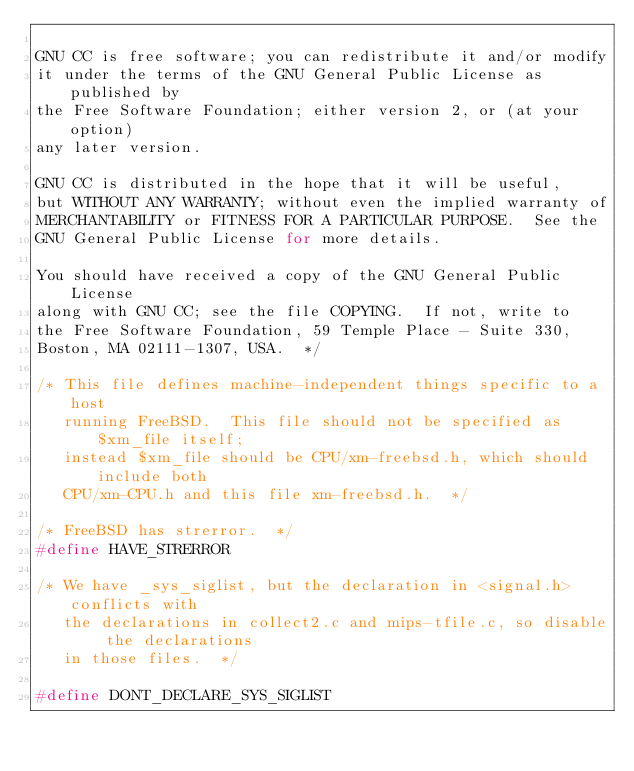<code> <loc_0><loc_0><loc_500><loc_500><_C_>
GNU CC is free software; you can redistribute it and/or modify
it under the terms of the GNU General Public License as published by
the Free Software Foundation; either version 2, or (at your option)
any later version.

GNU CC is distributed in the hope that it will be useful,
but WITHOUT ANY WARRANTY; without even the implied warranty of
MERCHANTABILITY or FITNESS FOR A PARTICULAR PURPOSE.  See the
GNU General Public License for more details.

You should have received a copy of the GNU General Public License
along with GNU CC; see the file COPYING.  If not, write to
the Free Software Foundation, 59 Temple Place - Suite 330,
Boston, MA 02111-1307, USA.  */

/* This file defines machine-independent things specific to a host
   running FreeBSD.  This file should not be specified as $xm_file itself;
   instead $xm_file should be CPU/xm-freebsd.h, which should include both
   CPU/xm-CPU.h and this file xm-freebsd.h.  */
   
/* FreeBSD has strerror.  */
#define HAVE_STRERROR

/* We have _sys_siglist, but the declaration in <signal.h> conflicts with
   the declarations in collect2.c and mips-tfile.c, so disable the declarations
   in those files.  */

#define DONT_DECLARE_SYS_SIGLIST
</code> 